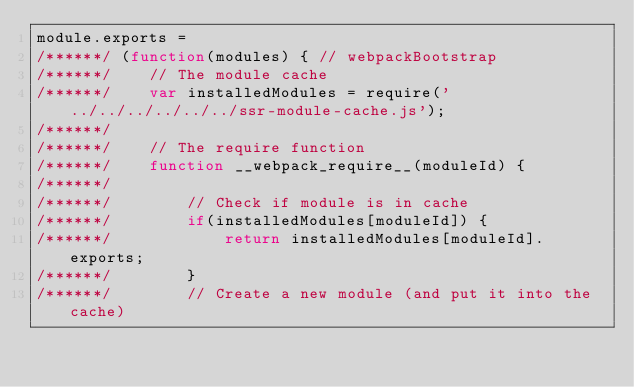<code> <loc_0><loc_0><loc_500><loc_500><_JavaScript_>module.exports =
/******/ (function(modules) { // webpackBootstrap
/******/ 	// The module cache
/******/ 	var installedModules = require('../../../../../../ssr-module-cache.js');
/******/
/******/ 	// The require function
/******/ 	function __webpack_require__(moduleId) {
/******/
/******/ 		// Check if module is in cache
/******/ 		if(installedModules[moduleId]) {
/******/ 			return installedModules[moduleId].exports;
/******/ 		}
/******/ 		// Create a new module (and put it into the cache)</code> 